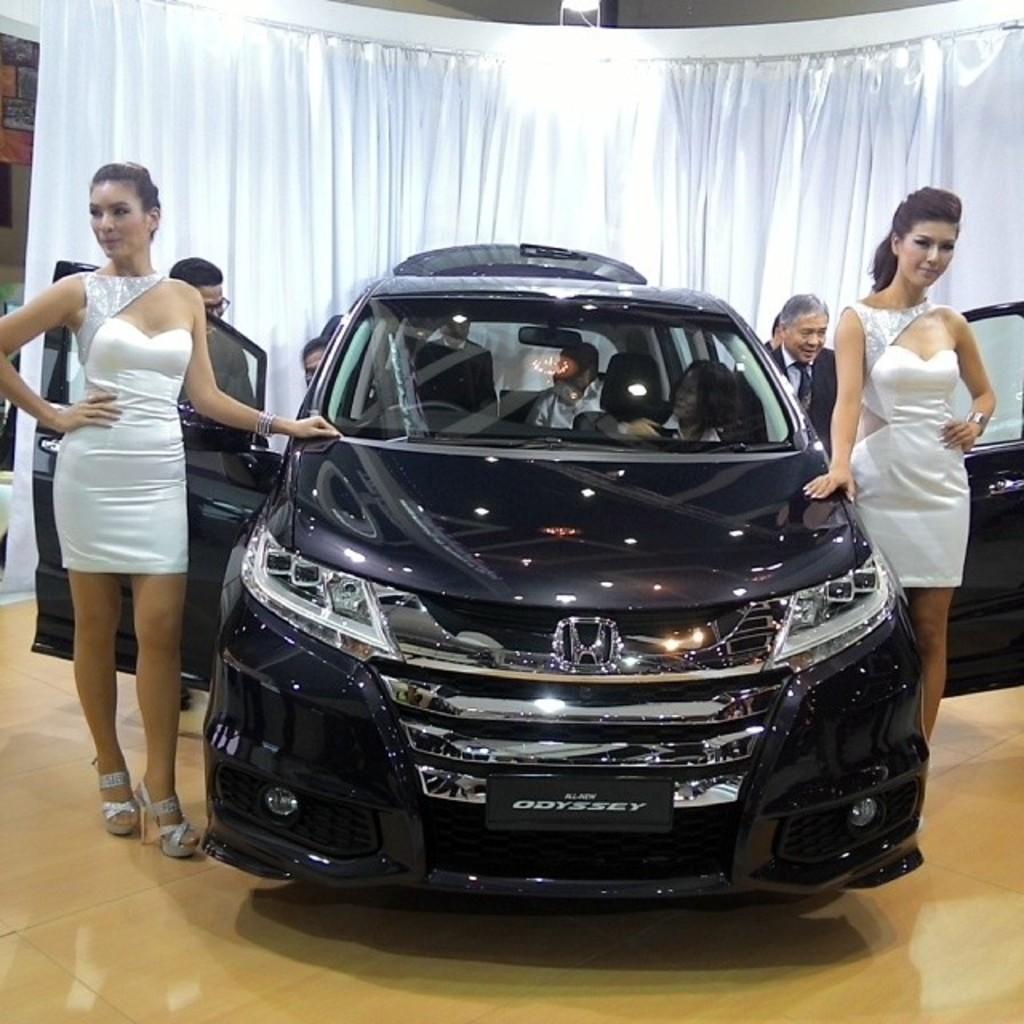In one or two sentences, can you explain what this image depicts? In this image there is a car, on either side of the car there are two ladies standing wearing a white dress, in the background there are people standing and there is a white curtain. 